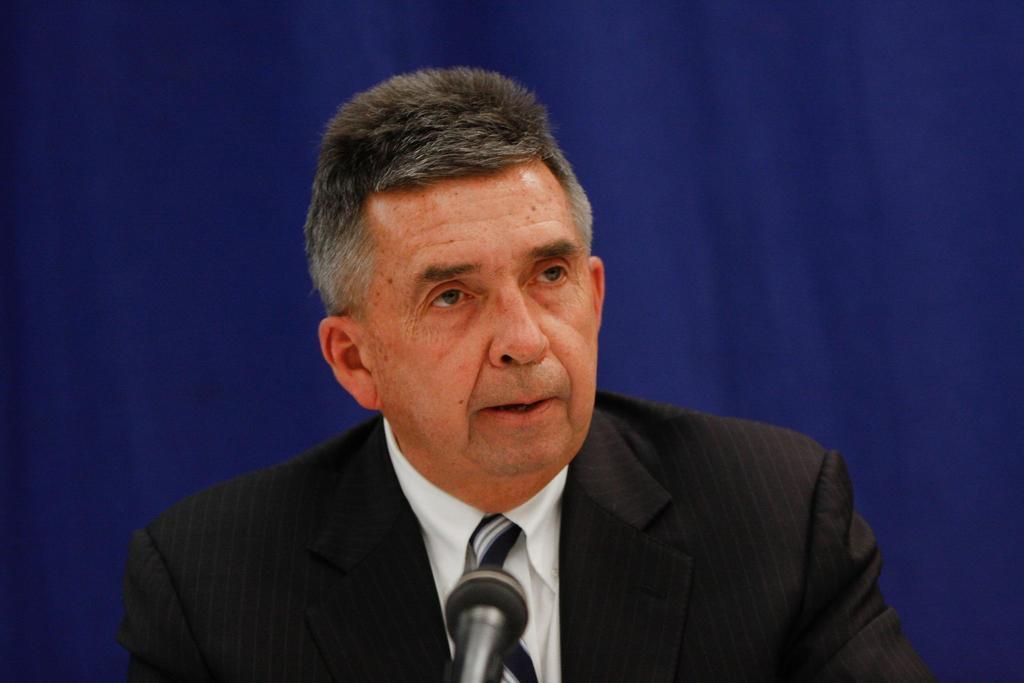How would you summarize this image in a sentence or two? In this image there is one person at middle of this image is wearing black color jacket and white color shirt and there is a mic at bottom of this image. 